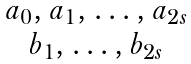<formula> <loc_0><loc_0><loc_500><loc_500>\begin{matrix} a _ { 0 } , a _ { 1 } , \dots , a _ { 2 s } \\ b _ { 1 } , \dots , b _ { 2 s } \end{matrix}</formula> 